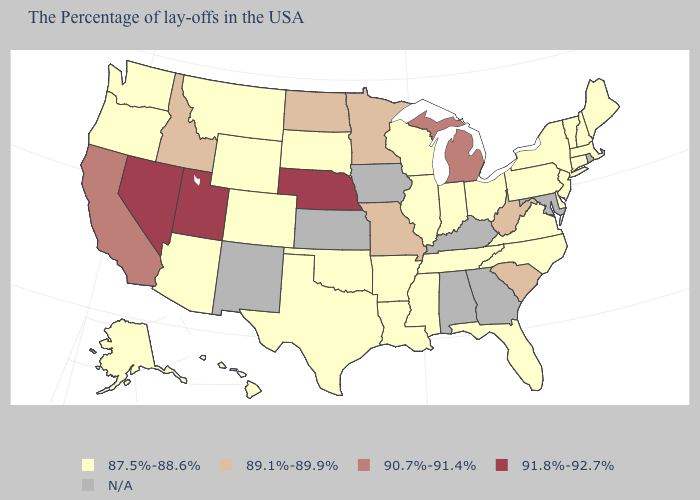What is the highest value in states that border Rhode Island?
Concise answer only. 87.5%-88.6%. What is the lowest value in the MidWest?
Answer briefly. 87.5%-88.6%. Is the legend a continuous bar?
Quick response, please. No. Name the states that have a value in the range N/A?
Concise answer only. Rhode Island, Maryland, Georgia, Kentucky, Alabama, Iowa, Kansas, New Mexico. Is the legend a continuous bar?
Be succinct. No. Among the states that border California , which have the lowest value?
Concise answer only. Arizona, Oregon. Name the states that have a value in the range 89.1%-89.9%?
Answer briefly. South Carolina, West Virginia, Missouri, Minnesota, North Dakota, Idaho. What is the lowest value in the USA?
Give a very brief answer. 87.5%-88.6%. What is the value of Texas?
Quick response, please. 87.5%-88.6%. What is the value of Indiana?
Give a very brief answer. 87.5%-88.6%. How many symbols are there in the legend?
Concise answer only. 5. Among the states that border Colorado , does Nebraska have the lowest value?
Answer briefly. No. 